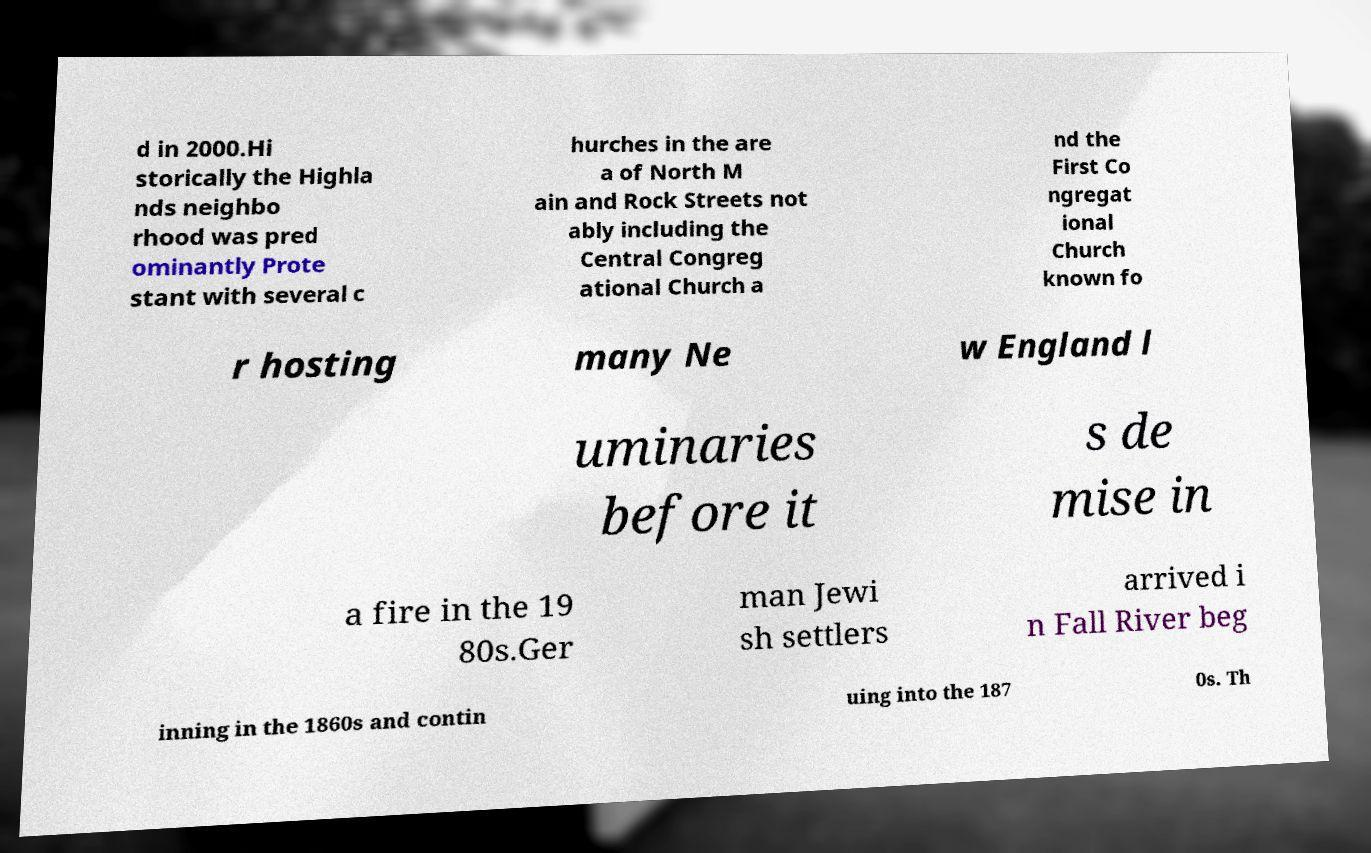Can you read and provide the text displayed in the image?This photo seems to have some interesting text. Can you extract and type it out for me? d in 2000.Hi storically the Highla nds neighbo rhood was pred ominantly Prote stant with several c hurches in the are a of North M ain and Rock Streets not ably including the Central Congreg ational Church a nd the First Co ngregat ional Church known fo r hosting many Ne w England l uminaries before it s de mise in a fire in the 19 80s.Ger man Jewi sh settlers arrived i n Fall River beg inning in the 1860s and contin uing into the 187 0s. Th 